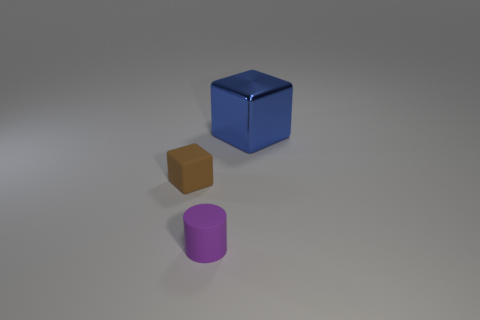Is the number of purple things behind the blue object greater than the number of big blue balls?
Your answer should be compact. No. Are the small thing that is left of the purple matte cylinder and the tiny purple object made of the same material?
Offer a terse response. Yes. There is a object that is behind the block in front of the big blue object behind the small purple object; what size is it?
Provide a short and direct response. Large. There is a brown object that is the same material as the small purple cylinder; what size is it?
Your answer should be very brief. Small. There is a thing that is in front of the big shiny thing and on the right side of the small brown cube; what color is it?
Provide a succinct answer. Purple. Is the shape of the large metallic thing behind the tiny cube the same as the rubber object that is behind the tiny purple rubber object?
Offer a terse response. Yes. What material is the cube to the left of the large metal block?
Keep it short and to the point. Rubber. How many objects are cubes on the left side of the blue cube or tiny blocks?
Your answer should be very brief. 1. Are there the same number of large metallic cubes behind the blue thing and matte cylinders?
Your answer should be compact. No. Is the size of the metal object the same as the matte cylinder?
Your response must be concise. No. 